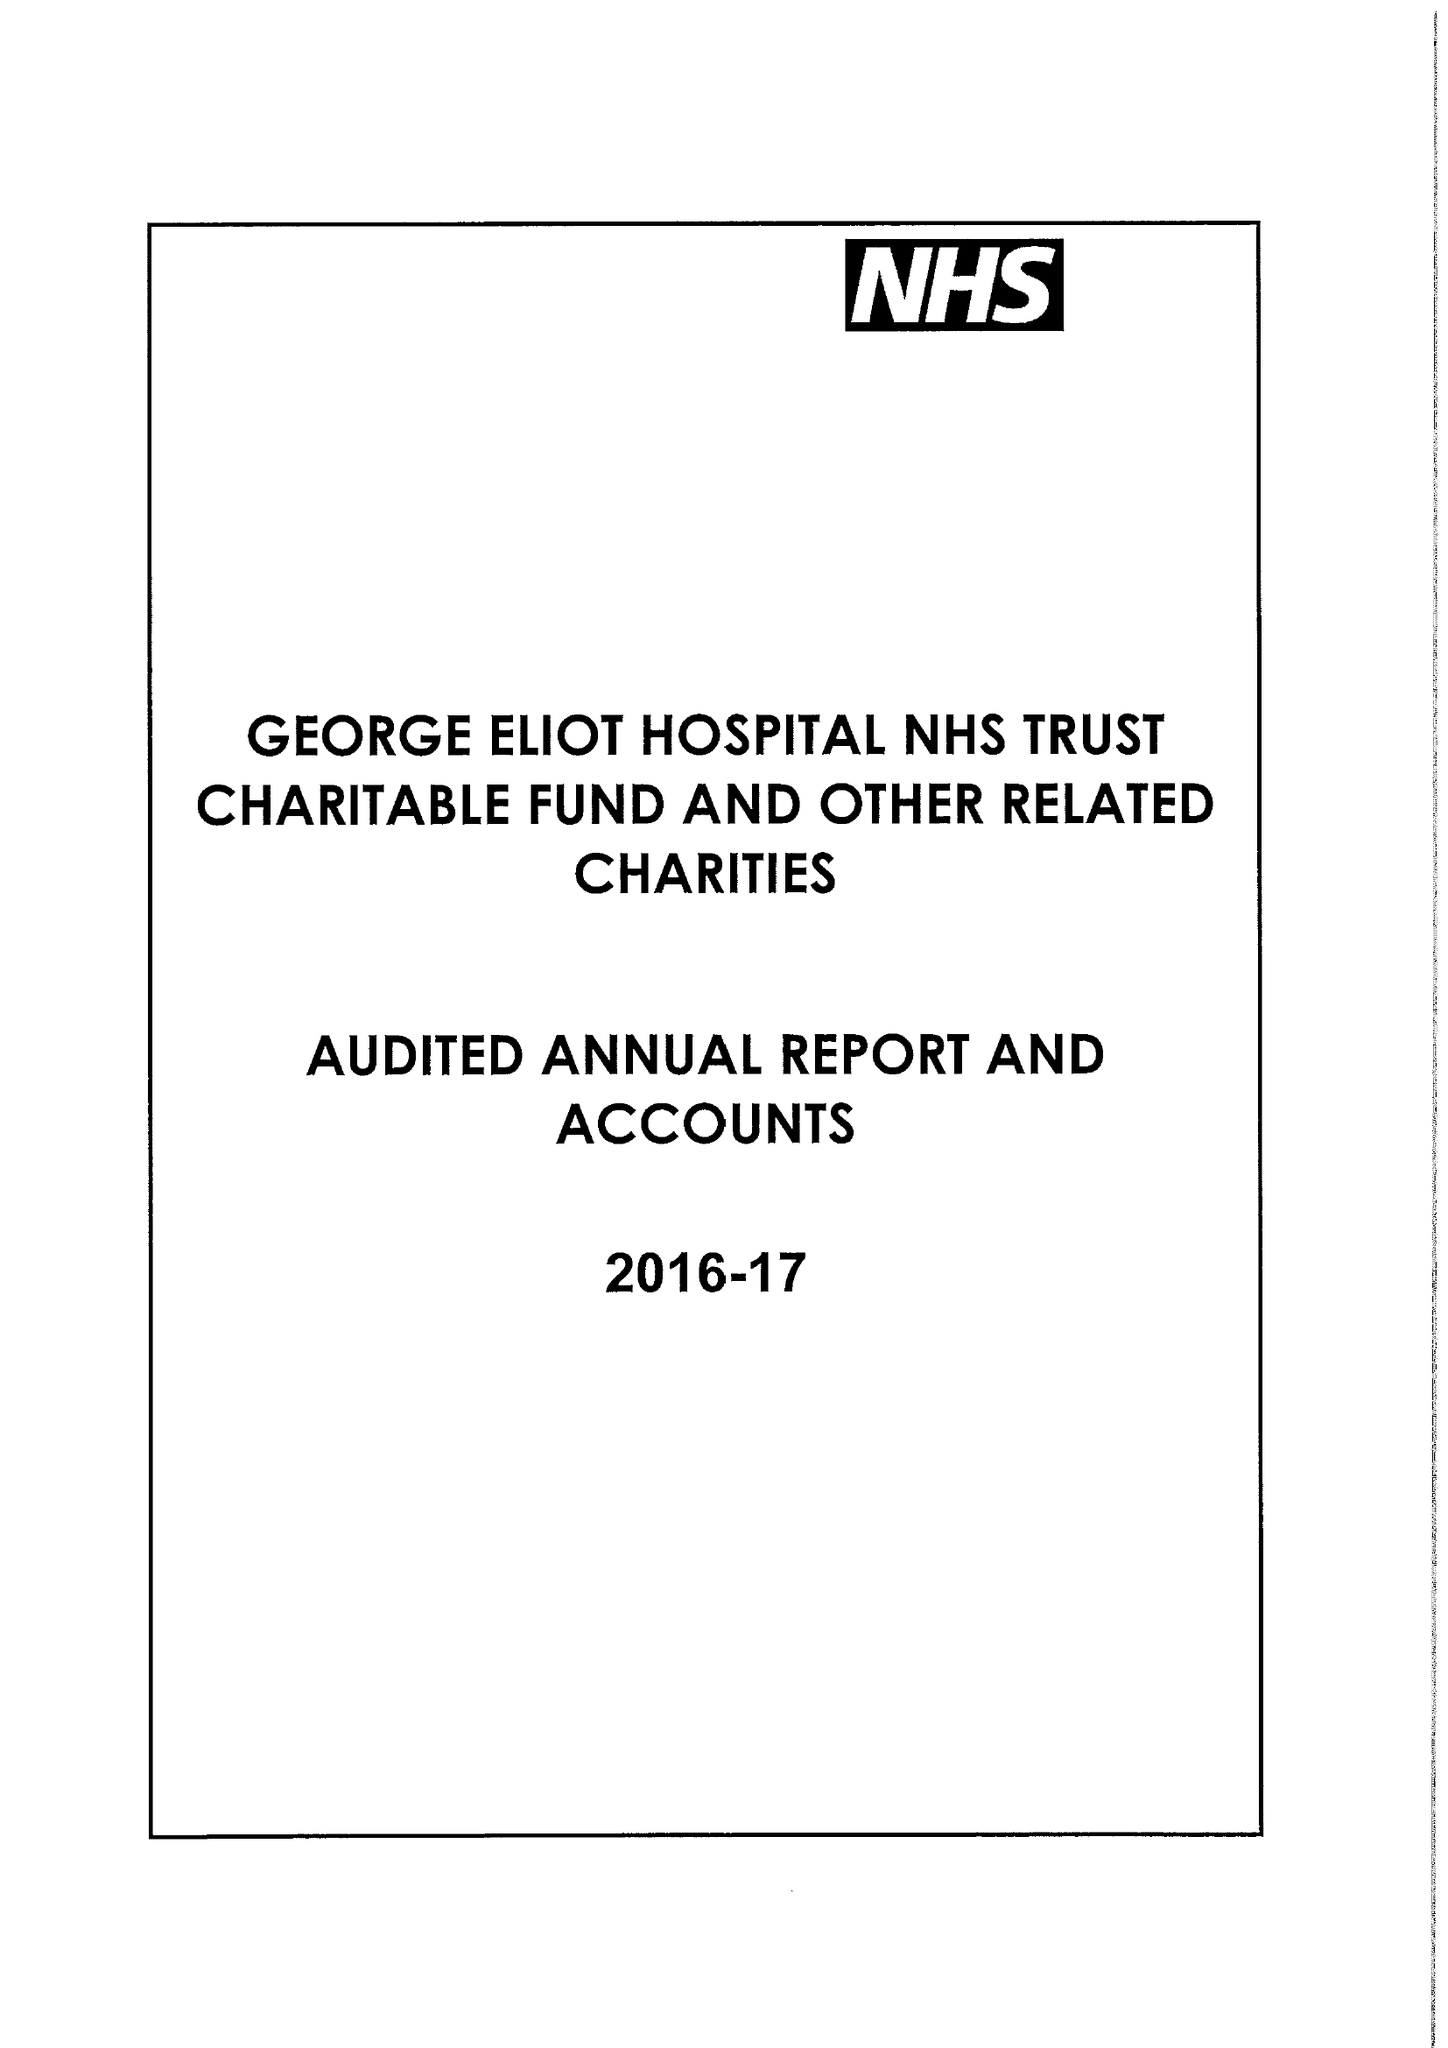What is the value for the spending_annually_in_british_pounds?
Answer the question using a single word or phrase. 175000.00 